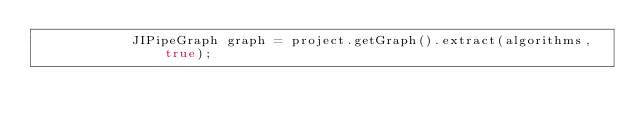Convert code to text. <code><loc_0><loc_0><loc_500><loc_500><_Java_>            JIPipeGraph graph = project.getGraph().extract(algorithms, true);</code> 